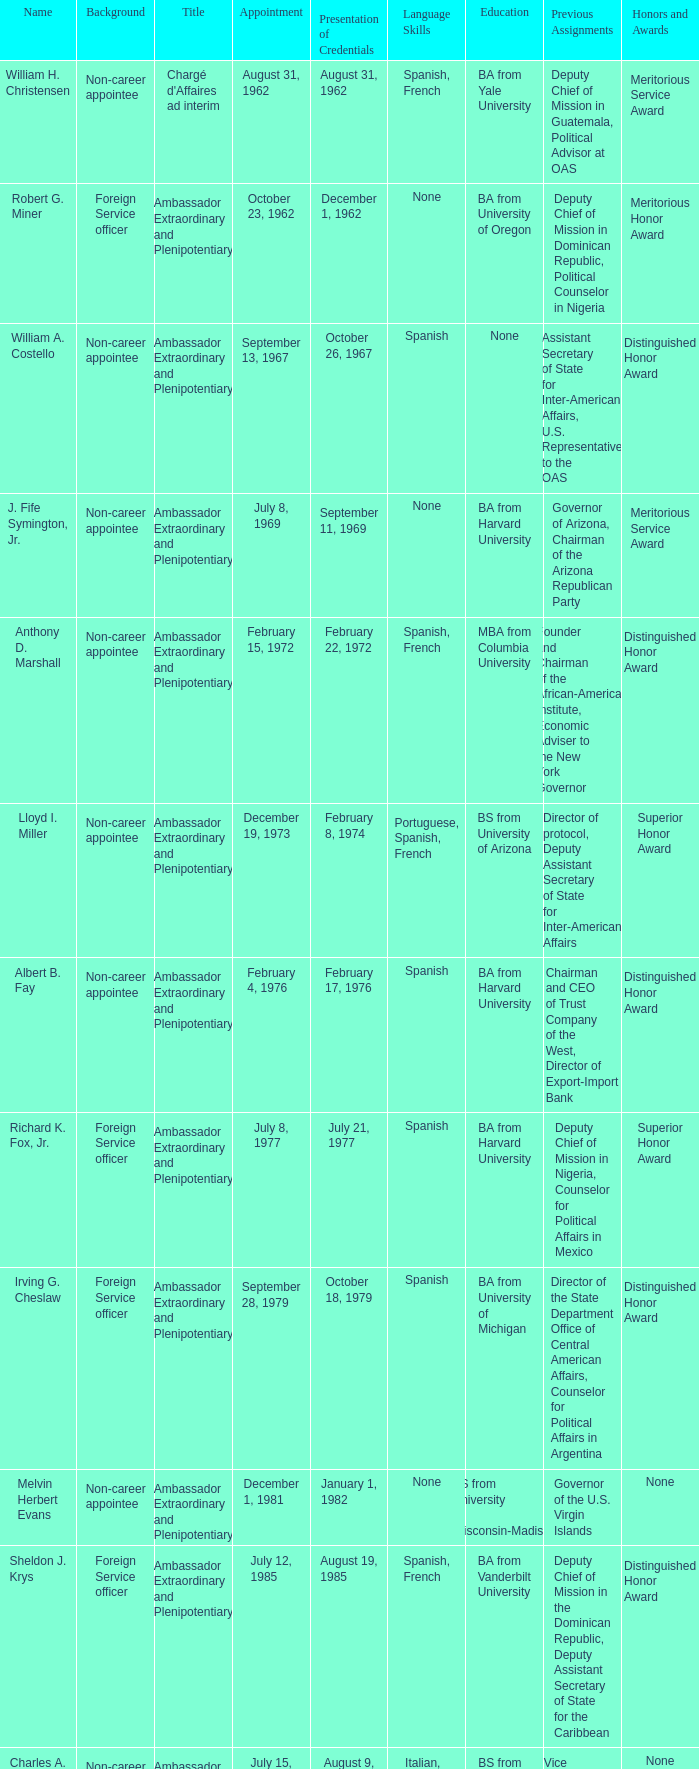Who was appointed on October 24, 1997? Edward E. Shumaker III. 